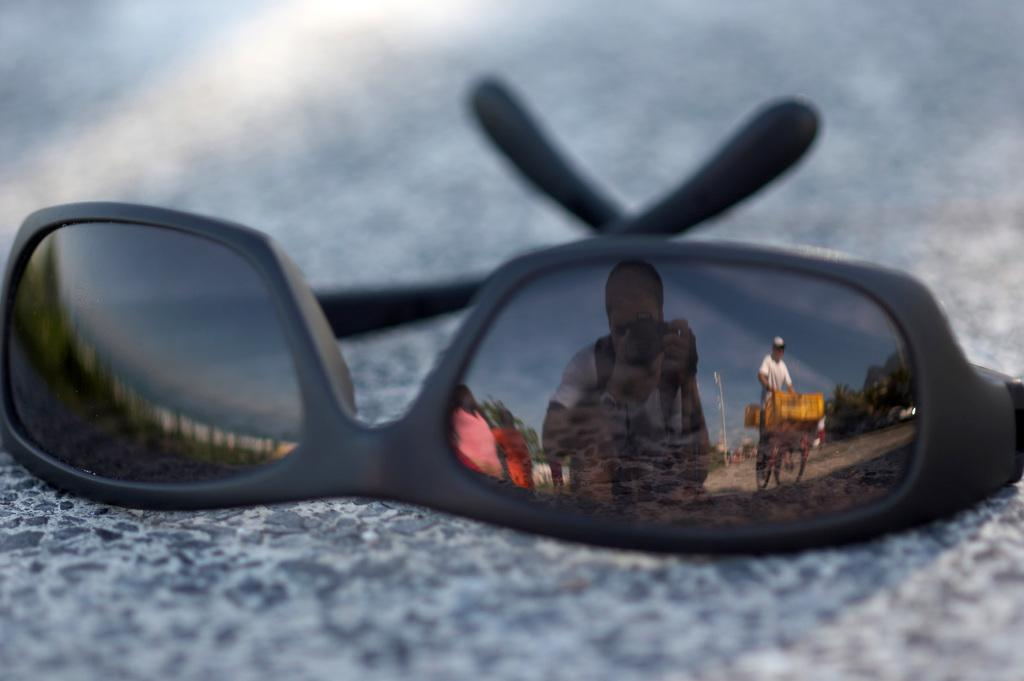What object is on the road in the image? There is a cooling glass on the road in the image. What can be seen in the cooling glass? The reflection of a man is visible on the cooling glass. What activity is taking place on the road in the image? There is a person cycling on the road in the image. What is the size of the boot in the image? There is no boot present in the image. 